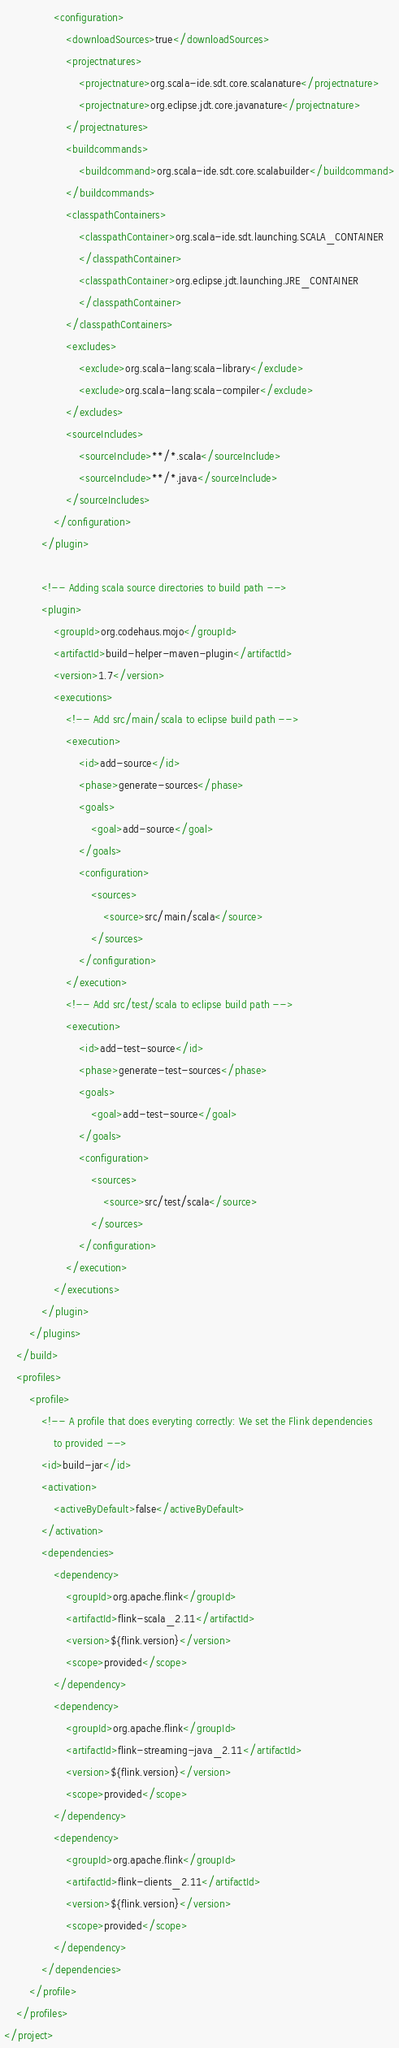<code> <loc_0><loc_0><loc_500><loc_500><_XML_>				<configuration>
					<downloadSources>true</downloadSources>
					<projectnatures>
						<projectnature>org.scala-ide.sdt.core.scalanature</projectnature>
						<projectnature>org.eclipse.jdt.core.javanature</projectnature>
					</projectnatures>
					<buildcommands>
						<buildcommand>org.scala-ide.sdt.core.scalabuilder</buildcommand>
					</buildcommands>
					<classpathContainers>
						<classpathContainer>org.scala-ide.sdt.launching.SCALA_CONTAINER
						</classpathContainer>
						<classpathContainer>org.eclipse.jdt.launching.JRE_CONTAINER
						</classpathContainer>
					</classpathContainers>
					<excludes>
						<exclude>org.scala-lang:scala-library</exclude>
						<exclude>org.scala-lang:scala-compiler</exclude>
					</excludes>
					<sourceIncludes>
						<sourceInclude>**/*.scala</sourceInclude>
						<sourceInclude>**/*.java</sourceInclude>
					</sourceIncludes>
				</configuration>
			</plugin>

			<!-- Adding scala source directories to build path -->
			<plugin>
				<groupId>org.codehaus.mojo</groupId>
				<artifactId>build-helper-maven-plugin</artifactId>
				<version>1.7</version>
				<executions>
					<!-- Add src/main/scala to eclipse build path -->
					<execution>
						<id>add-source</id>
						<phase>generate-sources</phase>
						<goals>
							<goal>add-source</goal>
						</goals>
						<configuration>
							<sources>
								<source>src/main/scala</source>
							</sources>
						</configuration>
					</execution>
					<!-- Add src/test/scala to eclipse build path -->
					<execution>
						<id>add-test-source</id>
						<phase>generate-test-sources</phase>
						<goals>
							<goal>add-test-source</goal>
						</goals>
						<configuration>
							<sources>
								<source>src/test/scala</source>
							</sources>
						</configuration>
					</execution>
				</executions>
			</plugin>
		</plugins>
	</build>
	<profiles>
		<profile>
			<!-- A profile that does everyting correctly: We set the Flink dependencies 
				to provided -->
			<id>build-jar</id>
			<activation>
				<activeByDefault>false</activeByDefault>
			</activation>
			<dependencies>
				<dependency>
					<groupId>org.apache.flink</groupId>
					<artifactId>flink-scala_2.11</artifactId>
					<version>${flink.version}</version>
					<scope>provided</scope>
				</dependency>
				<dependency>
					<groupId>org.apache.flink</groupId>
					<artifactId>flink-streaming-java_2.11</artifactId>
					<version>${flink.version}</version>
					<scope>provided</scope>
				</dependency>
				<dependency>
					<groupId>org.apache.flink</groupId>
					<artifactId>flink-clients_2.11</artifactId>
					<version>${flink.version}</version>
					<scope>provided</scope>
				</dependency>
			</dependencies>
		</profile>
	</profiles>
</project>
</code> 